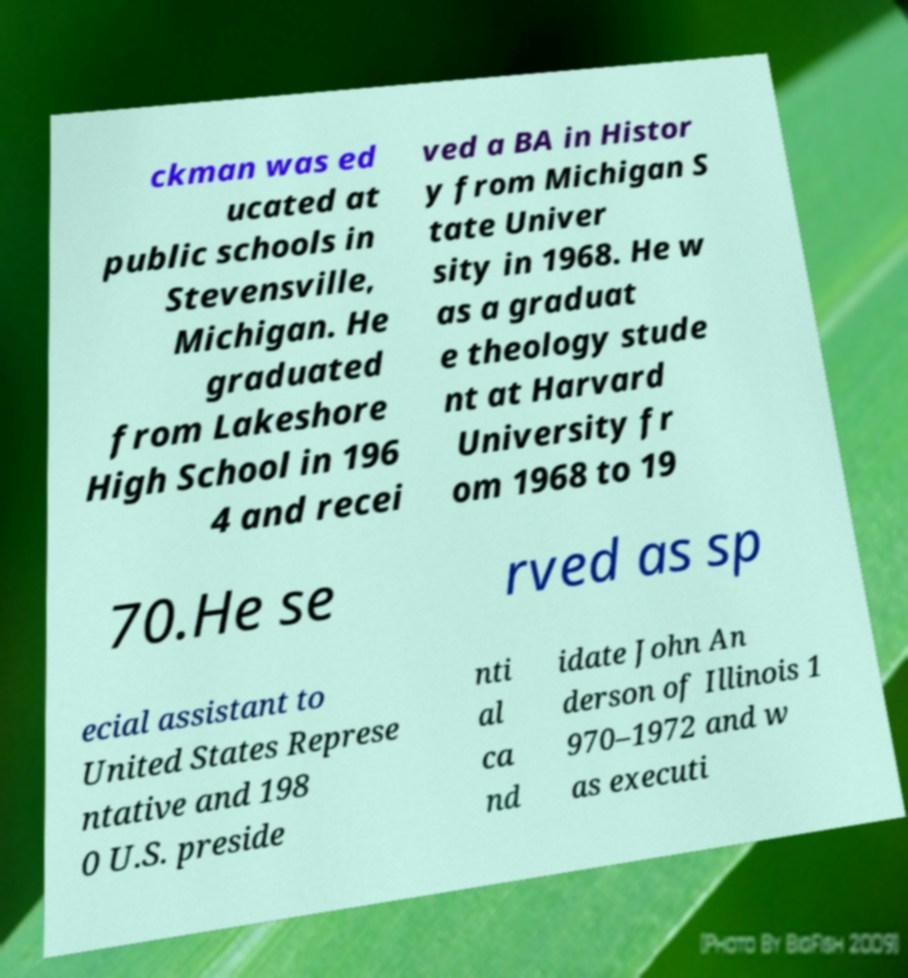Could you assist in decoding the text presented in this image and type it out clearly? ckman was ed ucated at public schools in Stevensville, Michigan. He graduated from Lakeshore High School in 196 4 and recei ved a BA in Histor y from Michigan S tate Univer sity in 1968. He w as a graduat e theology stude nt at Harvard University fr om 1968 to 19 70.He se rved as sp ecial assistant to United States Represe ntative and 198 0 U.S. preside nti al ca nd idate John An derson of Illinois 1 970–1972 and w as executi 